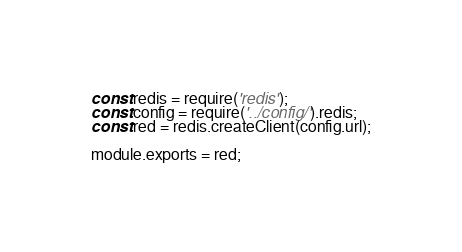<code> <loc_0><loc_0><loc_500><loc_500><_JavaScript_>const redis = require('redis');
const config = require('../config/').redis;
const red = redis.createClient(config.url);

module.exports = red;
</code> 